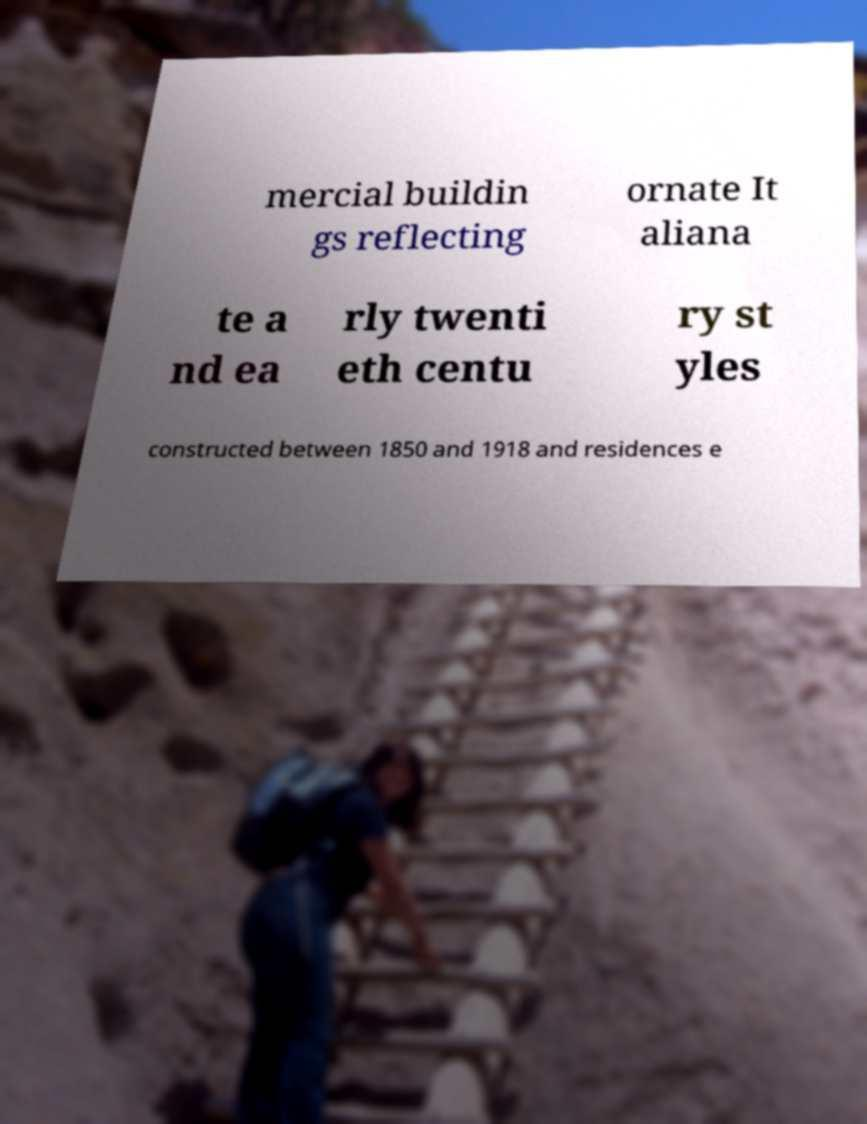Please identify and transcribe the text found in this image. mercial buildin gs reflecting ornate It aliana te a nd ea rly twenti eth centu ry st yles constructed between 1850 and 1918 and residences e 